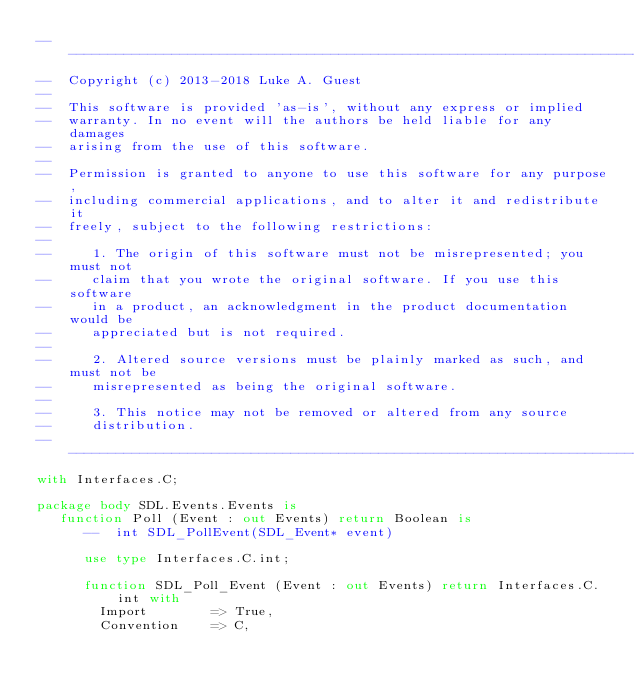Convert code to text. <code><loc_0><loc_0><loc_500><loc_500><_Ada_>--------------------------------------------------------------------------------------------------------------------
--  Copyright (c) 2013-2018 Luke A. Guest
--
--  This software is provided 'as-is', without any express or implied
--  warranty. In no event will the authors be held liable for any damages
--  arising from the use of this software.
--
--  Permission is granted to anyone to use this software for any purpose,
--  including commercial applications, and to alter it and redistribute it
--  freely, subject to the following restrictions:
--
--     1. The origin of this software must not be misrepresented; you must not
--     claim that you wrote the original software. If you use this software
--     in a product, an acknowledgment in the product documentation would be
--     appreciated but is not required.
--
--     2. Altered source versions must be plainly marked as such, and must not be
--     misrepresented as being the original software.
--
--     3. This notice may not be removed or altered from any source
--     distribution.
--------------------------------------------------------------------------------------------------------------------
with Interfaces.C;

package body SDL.Events.Events is
   function Poll (Event : out Events) return Boolean is
      --  int SDL_PollEvent(SDL_Event* event)

      use type Interfaces.C.int;

      function SDL_Poll_Event (Event : out Events) return Interfaces.C.int with
        Import        => True,
        Convention    => C,</code> 